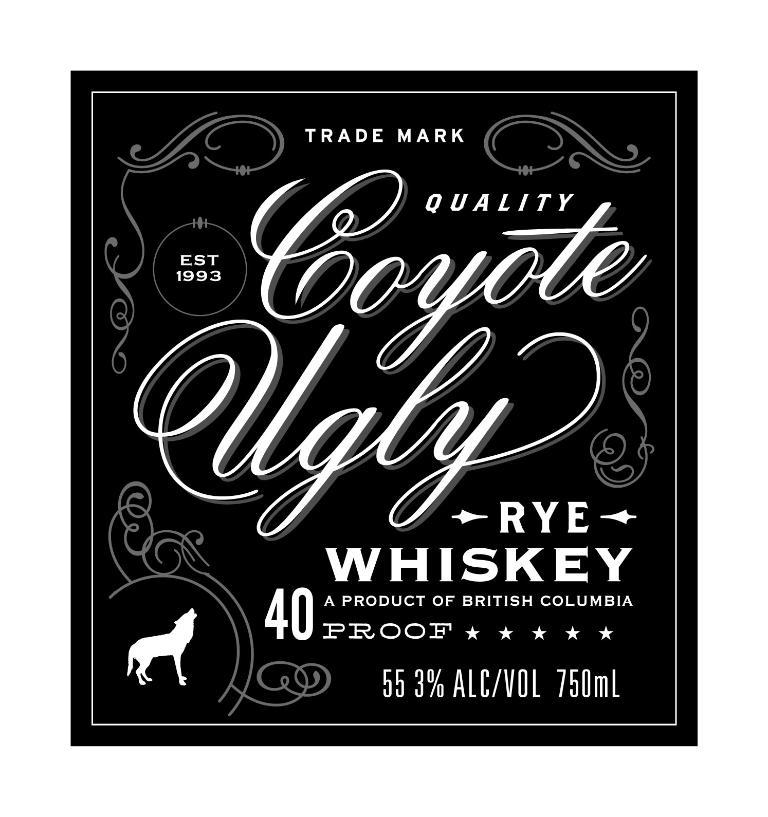What is the alcohol content of the whiskey?
Offer a terse response. 55.3. What is the name of this?
Provide a short and direct response. Coyote ugly. 